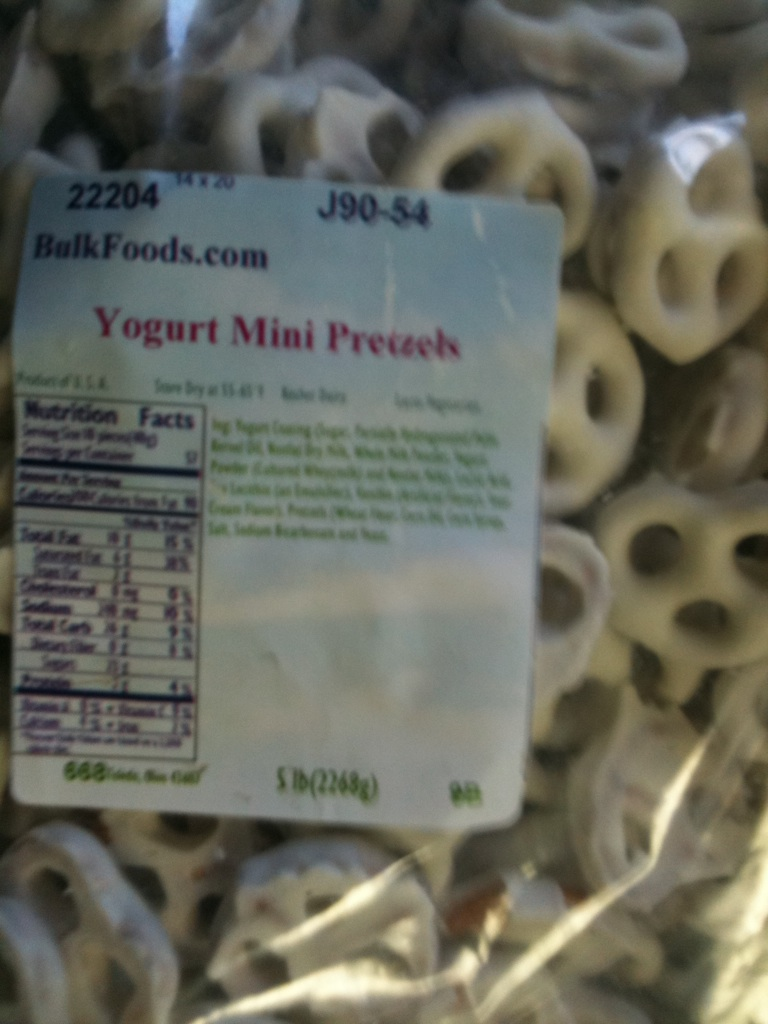Are these pretzels suitable for a health-conscious diet? Yogurt Mini Pretzels can be enjoyed as part of a balanced diet. While they offer a tasty treat, they do contain sugar and fats, so it is best to consume them in moderation as a good way to satisfy sweet cravings without overindulging. Checking the nutrition facts on the label can help you decide if they fit your dietary needs. Can you provide a creative recipe using these pretzels? Absolutely! Here's a fun and creative recipe: Yogurt Pretzel Crunch Trail Mix:

Ingredients:
- 1 cup Yogurt Mini Pretzels
- 1/2 cup dried cranberries
- 1/2 cup roasted almonds
- 1/2 cup dark chocolate chips
- 1/4 cup coconut flakes

Instructions:
1. In a large bowl, mix all the ingredients together.
2. Store in an airtight container.
3. Enjoy as a quick snack on the go, perfect for hiking or as an afternoon pick-me-up! 